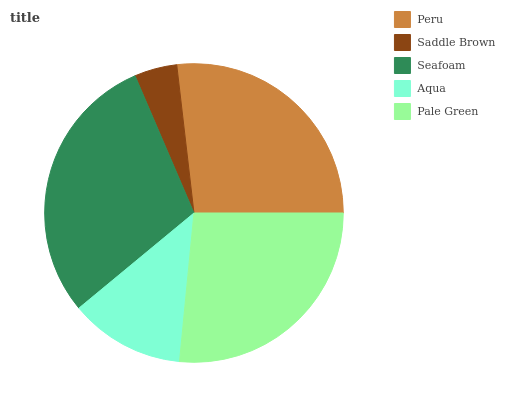Is Saddle Brown the minimum?
Answer yes or no. Yes. Is Seafoam the maximum?
Answer yes or no. Yes. Is Seafoam the minimum?
Answer yes or no. No. Is Saddle Brown the maximum?
Answer yes or no. No. Is Seafoam greater than Saddle Brown?
Answer yes or no. Yes. Is Saddle Brown less than Seafoam?
Answer yes or no. Yes. Is Saddle Brown greater than Seafoam?
Answer yes or no. No. Is Seafoam less than Saddle Brown?
Answer yes or no. No. Is Pale Green the high median?
Answer yes or no. Yes. Is Pale Green the low median?
Answer yes or no. Yes. Is Peru the high median?
Answer yes or no. No. Is Peru the low median?
Answer yes or no. No. 